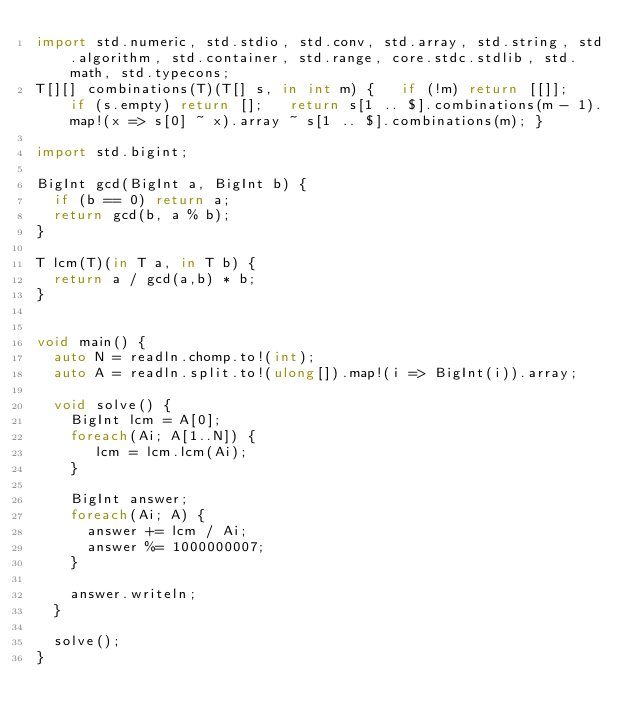Convert code to text. <code><loc_0><loc_0><loc_500><loc_500><_D_>import std.numeric, std.stdio, std.conv, std.array, std.string, std.algorithm, std.container, std.range, core.stdc.stdlib, std.math, std.typecons;
T[][] combinations(T)(T[] s, in int m) {   if (!m) return [[]];   if (s.empty) return [];   return s[1 .. $].combinations(m - 1).map!(x => s[0] ~ x).array ~ s[1 .. $].combinations(m); }

import std.bigint;

BigInt gcd(BigInt a, BigInt b) {
  if (b == 0) return a;
  return gcd(b, a % b);
}

T lcm(T)(in T a, in T b) {
  return a / gcd(a,b) * b;
}


void main() {
  auto N = readln.chomp.to!(int);
  auto A = readln.split.to!(ulong[]).map!(i => BigInt(i)).array;

  void solve() {
    BigInt lcm = A[0];
    foreach(Ai; A[1..N]) {
       lcm = lcm.lcm(Ai);
    }

    BigInt answer;
    foreach(Ai; A) {
      answer += lcm / Ai;
      answer %= 1000000007;
    }

    answer.writeln;
  }

  solve();
}
</code> 